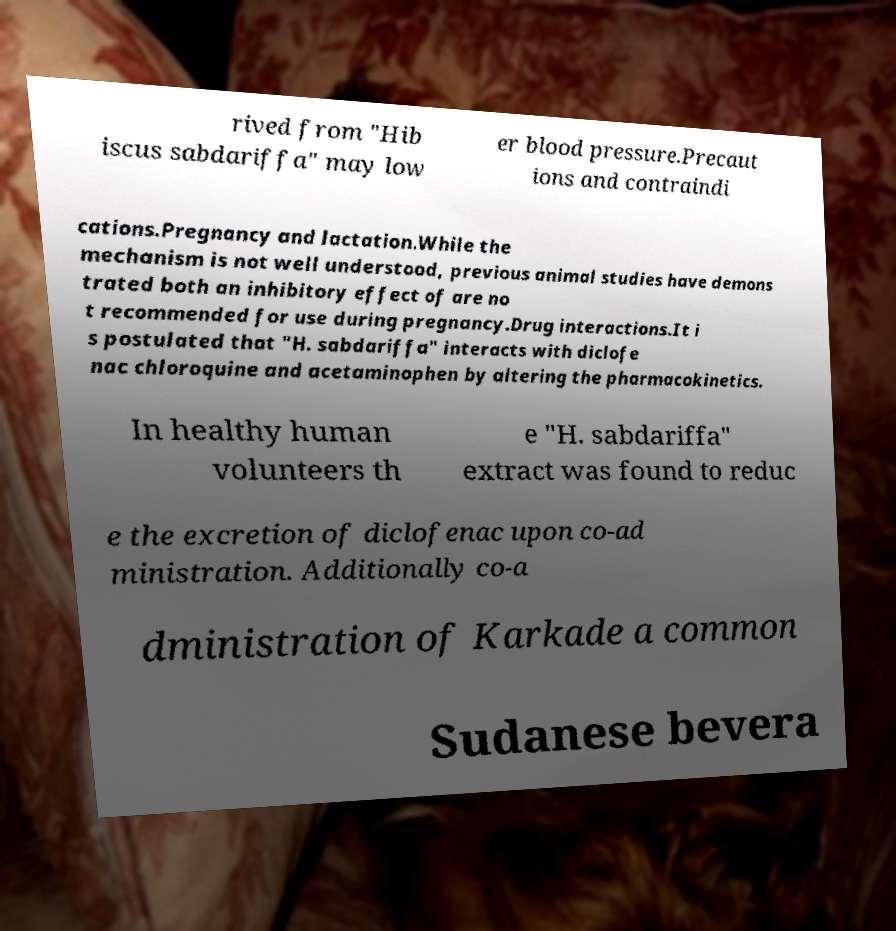For documentation purposes, I need the text within this image transcribed. Could you provide that? rived from "Hib iscus sabdariffa" may low er blood pressure.Precaut ions and contraindi cations.Pregnancy and lactation.While the mechanism is not well understood, previous animal studies have demons trated both an inhibitory effect of are no t recommended for use during pregnancy.Drug interactions.It i s postulated that "H. sabdariffa" interacts with diclofe nac chloroquine and acetaminophen by altering the pharmacokinetics. In healthy human volunteers th e "H. sabdariffa" extract was found to reduc e the excretion of diclofenac upon co-ad ministration. Additionally co-a dministration of Karkade a common Sudanese bevera 